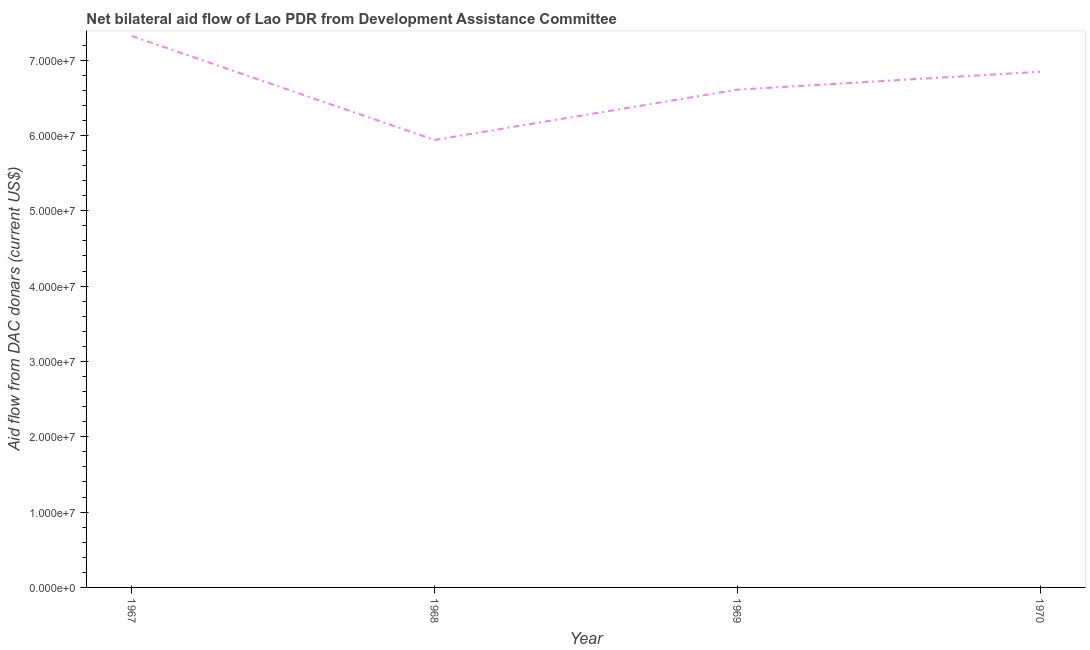What is the net bilateral aid flows from dac donors in 1970?
Your answer should be compact. 6.85e+07. Across all years, what is the maximum net bilateral aid flows from dac donors?
Provide a short and direct response. 7.32e+07. Across all years, what is the minimum net bilateral aid flows from dac donors?
Offer a terse response. 5.94e+07. In which year was the net bilateral aid flows from dac donors maximum?
Provide a short and direct response. 1967. In which year was the net bilateral aid flows from dac donors minimum?
Keep it short and to the point. 1968. What is the sum of the net bilateral aid flows from dac donors?
Provide a short and direct response. 2.67e+08. What is the difference between the net bilateral aid flows from dac donors in 1968 and 1970?
Your answer should be compact. -9.06e+06. What is the average net bilateral aid flows from dac donors per year?
Offer a very short reply. 6.68e+07. What is the median net bilateral aid flows from dac donors?
Your answer should be very brief. 6.73e+07. In how many years, is the net bilateral aid flows from dac donors greater than 46000000 US$?
Your response must be concise. 4. What is the ratio of the net bilateral aid flows from dac donors in 1968 to that in 1970?
Make the answer very short. 0.87. What is the difference between the highest and the second highest net bilateral aid flows from dac donors?
Give a very brief answer. 4.74e+06. Is the sum of the net bilateral aid flows from dac donors in 1968 and 1969 greater than the maximum net bilateral aid flows from dac donors across all years?
Offer a terse response. Yes. What is the difference between the highest and the lowest net bilateral aid flows from dac donors?
Provide a succinct answer. 1.38e+07. What is the difference between two consecutive major ticks on the Y-axis?
Make the answer very short. 1.00e+07. What is the title of the graph?
Your response must be concise. Net bilateral aid flow of Lao PDR from Development Assistance Committee. What is the label or title of the Y-axis?
Ensure brevity in your answer.  Aid flow from DAC donars (current US$). What is the Aid flow from DAC donars (current US$) in 1967?
Your response must be concise. 7.32e+07. What is the Aid flow from DAC donars (current US$) of 1968?
Your response must be concise. 5.94e+07. What is the Aid flow from DAC donars (current US$) of 1969?
Ensure brevity in your answer.  6.61e+07. What is the Aid flow from DAC donars (current US$) in 1970?
Your answer should be compact. 6.85e+07. What is the difference between the Aid flow from DAC donars (current US$) in 1967 and 1968?
Your answer should be compact. 1.38e+07. What is the difference between the Aid flow from DAC donars (current US$) in 1967 and 1969?
Ensure brevity in your answer.  7.12e+06. What is the difference between the Aid flow from DAC donars (current US$) in 1967 and 1970?
Keep it short and to the point. 4.74e+06. What is the difference between the Aid flow from DAC donars (current US$) in 1968 and 1969?
Provide a succinct answer. -6.68e+06. What is the difference between the Aid flow from DAC donars (current US$) in 1968 and 1970?
Give a very brief answer. -9.06e+06. What is the difference between the Aid flow from DAC donars (current US$) in 1969 and 1970?
Keep it short and to the point. -2.38e+06. What is the ratio of the Aid flow from DAC donars (current US$) in 1967 to that in 1968?
Provide a short and direct response. 1.23. What is the ratio of the Aid flow from DAC donars (current US$) in 1967 to that in 1969?
Your answer should be compact. 1.11. What is the ratio of the Aid flow from DAC donars (current US$) in 1967 to that in 1970?
Your answer should be very brief. 1.07. What is the ratio of the Aid flow from DAC donars (current US$) in 1968 to that in 1969?
Your answer should be very brief. 0.9. What is the ratio of the Aid flow from DAC donars (current US$) in 1968 to that in 1970?
Ensure brevity in your answer.  0.87. 